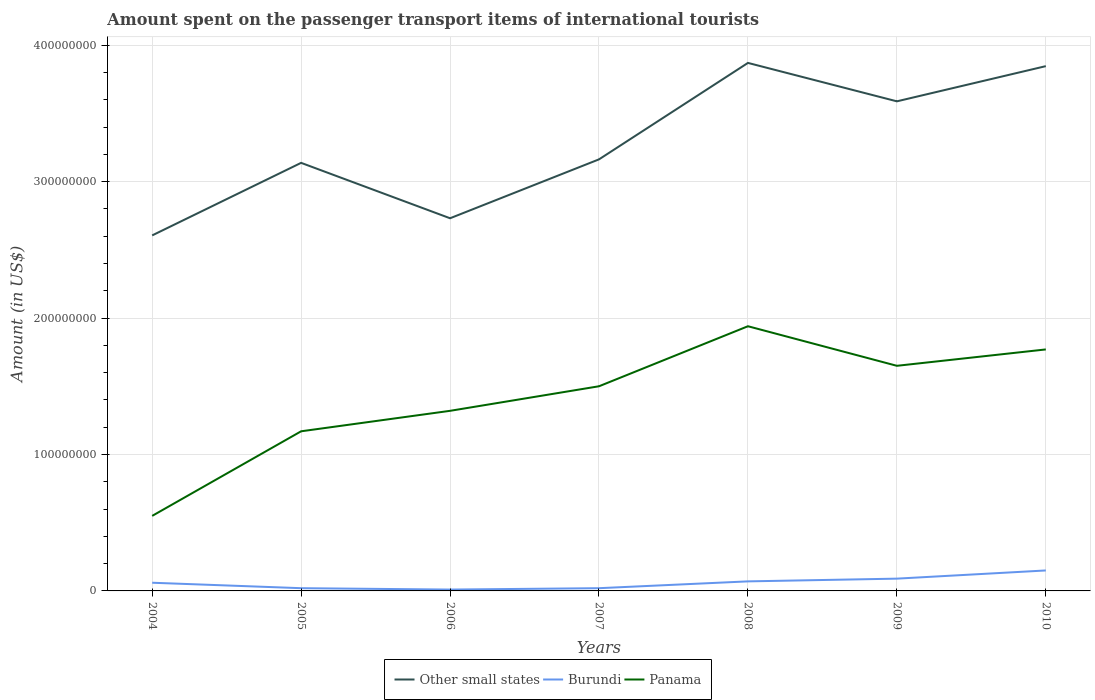How many different coloured lines are there?
Make the answer very short. 3. Is the number of lines equal to the number of legend labels?
Provide a short and direct response. Yes. What is the total amount spent on the passenger transport items of international tourists in Other small states in the graph?
Offer a terse response. -1.26e+08. What is the difference between the highest and the second highest amount spent on the passenger transport items of international tourists in Panama?
Offer a very short reply. 1.39e+08. Is the amount spent on the passenger transport items of international tourists in Burundi strictly greater than the amount spent on the passenger transport items of international tourists in Panama over the years?
Your answer should be very brief. Yes. How many lines are there?
Offer a very short reply. 3. How many years are there in the graph?
Offer a terse response. 7. What is the difference between two consecutive major ticks on the Y-axis?
Your answer should be very brief. 1.00e+08. Are the values on the major ticks of Y-axis written in scientific E-notation?
Give a very brief answer. No. Does the graph contain any zero values?
Make the answer very short. No. Where does the legend appear in the graph?
Give a very brief answer. Bottom center. How many legend labels are there?
Offer a terse response. 3. What is the title of the graph?
Offer a very short reply. Amount spent on the passenger transport items of international tourists. What is the label or title of the X-axis?
Make the answer very short. Years. What is the Amount (in US$) of Other small states in 2004?
Your answer should be very brief. 2.61e+08. What is the Amount (in US$) in Panama in 2004?
Make the answer very short. 5.50e+07. What is the Amount (in US$) in Other small states in 2005?
Provide a succinct answer. 3.14e+08. What is the Amount (in US$) of Panama in 2005?
Keep it short and to the point. 1.17e+08. What is the Amount (in US$) of Other small states in 2006?
Provide a succinct answer. 2.73e+08. What is the Amount (in US$) of Panama in 2006?
Your answer should be very brief. 1.32e+08. What is the Amount (in US$) of Other small states in 2007?
Keep it short and to the point. 3.16e+08. What is the Amount (in US$) in Panama in 2007?
Offer a terse response. 1.50e+08. What is the Amount (in US$) of Other small states in 2008?
Keep it short and to the point. 3.87e+08. What is the Amount (in US$) in Panama in 2008?
Ensure brevity in your answer.  1.94e+08. What is the Amount (in US$) of Other small states in 2009?
Make the answer very short. 3.59e+08. What is the Amount (in US$) of Burundi in 2009?
Your answer should be very brief. 9.00e+06. What is the Amount (in US$) of Panama in 2009?
Keep it short and to the point. 1.65e+08. What is the Amount (in US$) of Other small states in 2010?
Give a very brief answer. 3.85e+08. What is the Amount (in US$) in Burundi in 2010?
Provide a succinct answer. 1.50e+07. What is the Amount (in US$) of Panama in 2010?
Provide a short and direct response. 1.77e+08. Across all years, what is the maximum Amount (in US$) in Other small states?
Your answer should be compact. 3.87e+08. Across all years, what is the maximum Amount (in US$) in Burundi?
Your response must be concise. 1.50e+07. Across all years, what is the maximum Amount (in US$) of Panama?
Keep it short and to the point. 1.94e+08. Across all years, what is the minimum Amount (in US$) in Other small states?
Provide a succinct answer. 2.61e+08. Across all years, what is the minimum Amount (in US$) in Burundi?
Keep it short and to the point. 1.00e+06. Across all years, what is the minimum Amount (in US$) of Panama?
Your answer should be very brief. 5.50e+07. What is the total Amount (in US$) in Other small states in the graph?
Make the answer very short. 2.29e+09. What is the total Amount (in US$) in Burundi in the graph?
Make the answer very short. 4.20e+07. What is the total Amount (in US$) of Panama in the graph?
Your answer should be very brief. 9.90e+08. What is the difference between the Amount (in US$) in Other small states in 2004 and that in 2005?
Offer a very short reply. -5.32e+07. What is the difference between the Amount (in US$) in Burundi in 2004 and that in 2005?
Keep it short and to the point. 4.00e+06. What is the difference between the Amount (in US$) of Panama in 2004 and that in 2005?
Your response must be concise. -6.20e+07. What is the difference between the Amount (in US$) of Other small states in 2004 and that in 2006?
Your response must be concise. -1.26e+07. What is the difference between the Amount (in US$) in Panama in 2004 and that in 2006?
Ensure brevity in your answer.  -7.70e+07. What is the difference between the Amount (in US$) of Other small states in 2004 and that in 2007?
Your response must be concise. -5.57e+07. What is the difference between the Amount (in US$) of Panama in 2004 and that in 2007?
Your answer should be compact. -9.50e+07. What is the difference between the Amount (in US$) in Other small states in 2004 and that in 2008?
Your answer should be very brief. -1.26e+08. What is the difference between the Amount (in US$) in Panama in 2004 and that in 2008?
Offer a terse response. -1.39e+08. What is the difference between the Amount (in US$) of Other small states in 2004 and that in 2009?
Give a very brief answer. -9.83e+07. What is the difference between the Amount (in US$) in Burundi in 2004 and that in 2009?
Ensure brevity in your answer.  -3.00e+06. What is the difference between the Amount (in US$) of Panama in 2004 and that in 2009?
Provide a succinct answer. -1.10e+08. What is the difference between the Amount (in US$) of Other small states in 2004 and that in 2010?
Your answer should be compact. -1.24e+08. What is the difference between the Amount (in US$) of Burundi in 2004 and that in 2010?
Provide a succinct answer. -9.00e+06. What is the difference between the Amount (in US$) in Panama in 2004 and that in 2010?
Make the answer very short. -1.22e+08. What is the difference between the Amount (in US$) of Other small states in 2005 and that in 2006?
Ensure brevity in your answer.  4.06e+07. What is the difference between the Amount (in US$) of Panama in 2005 and that in 2006?
Keep it short and to the point. -1.50e+07. What is the difference between the Amount (in US$) of Other small states in 2005 and that in 2007?
Ensure brevity in your answer.  -2.56e+06. What is the difference between the Amount (in US$) of Panama in 2005 and that in 2007?
Provide a succinct answer. -3.30e+07. What is the difference between the Amount (in US$) in Other small states in 2005 and that in 2008?
Your response must be concise. -7.33e+07. What is the difference between the Amount (in US$) in Burundi in 2005 and that in 2008?
Give a very brief answer. -5.00e+06. What is the difference between the Amount (in US$) of Panama in 2005 and that in 2008?
Provide a succinct answer. -7.70e+07. What is the difference between the Amount (in US$) of Other small states in 2005 and that in 2009?
Keep it short and to the point. -4.51e+07. What is the difference between the Amount (in US$) in Burundi in 2005 and that in 2009?
Provide a short and direct response. -7.00e+06. What is the difference between the Amount (in US$) in Panama in 2005 and that in 2009?
Provide a short and direct response. -4.80e+07. What is the difference between the Amount (in US$) of Other small states in 2005 and that in 2010?
Provide a succinct answer. -7.09e+07. What is the difference between the Amount (in US$) of Burundi in 2005 and that in 2010?
Ensure brevity in your answer.  -1.30e+07. What is the difference between the Amount (in US$) in Panama in 2005 and that in 2010?
Your answer should be compact. -6.00e+07. What is the difference between the Amount (in US$) in Other small states in 2006 and that in 2007?
Ensure brevity in your answer.  -4.32e+07. What is the difference between the Amount (in US$) in Panama in 2006 and that in 2007?
Ensure brevity in your answer.  -1.80e+07. What is the difference between the Amount (in US$) in Other small states in 2006 and that in 2008?
Offer a very short reply. -1.14e+08. What is the difference between the Amount (in US$) in Burundi in 2006 and that in 2008?
Give a very brief answer. -6.00e+06. What is the difference between the Amount (in US$) of Panama in 2006 and that in 2008?
Give a very brief answer. -6.20e+07. What is the difference between the Amount (in US$) in Other small states in 2006 and that in 2009?
Provide a succinct answer. -8.57e+07. What is the difference between the Amount (in US$) of Burundi in 2006 and that in 2009?
Give a very brief answer. -8.00e+06. What is the difference between the Amount (in US$) in Panama in 2006 and that in 2009?
Provide a short and direct response. -3.30e+07. What is the difference between the Amount (in US$) in Other small states in 2006 and that in 2010?
Make the answer very short. -1.11e+08. What is the difference between the Amount (in US$) in Burundi in 2006 and that in 2010?
Keep it short and to the point. -1.40e+07. What is the difference between the Amount (in US$) in Panama in 2006 and that in 2010?
Your response must be concise. -4.50e+07. What is the difference between the Amount (in US$) of Other small states in 2007 and that in 2008?
Your response must be concise. -7.07e+07. What is the difference between the Amount (in US$) in Burundi in 2007 and that in 2008?
Ensure brevity in your answer.  -5.00e+06. What is the difference between the Amount (in US$) in Panama in 2007 and that in 2008?
Give a very brief answer. -4.40e+07. What is the difference between the Amount (in US$) of Other small states in 2007 and that in 2009?
Your answer should be very brief. -4.25e+07. What is the difference between the Amount (in US$) in Burundi in 2007 and that in 2009?
Your answer should be compact. -7.00e+06. What is the difference between the Amount (in US$) in Panama in 2007 and that in 2009?
Offer a very short reply. -1.50e+07. What is the difference between the Amount (in US$) of Other small states in 2007 and that in 2010?
Provide a succinct answer. -6.83e+07. What is the difference between the Amount (in US$) of Burundi in 2007 and that in 2010?
Offer a very short reply. -1.30e+07. What is the difference between the Amount (in US$) in Panama in 2007 and that in 2010?
Offer a very short reply. -2.70e+07. What is the difference between the Amount (in US$) in Other small states in 2008 and that in 2009?
Offer a terse response. 2.82e+07. What is the difference between the Amount (in US$) in Panama in 2008 and that in 2009?
Offer a terse response. 2.90e+07. What is the difference between the Amount (in US$) of Other small states in 2008 and that in 2010?
Provide a short and direct response. 2.37e+06. What is the difference between the Amount (in US$) in Burundi in 2008 and that in 2010?
Offer a terse response. -8.00e+06. What is the difference between the Amount (in US$) of Panama in 2008 and that in 2010?
Ensure brevity in your answer.  1.70e+07. What is the difference between the Amount (in US$) in Other small states in 2009 and that in 2010?
Your answer should be very brief. -2.58e+07. What is the difference between the Amount (in US$) of Burundi in 2009 and that in 2010?
Offer a very short reply. -6.00e+06. What is the difference between the Amount (in US$) of Panama in 2009 and that in 2010?
Offer a terse response. -1.20e+07. What is the difference between the Amount (in US$) in Other small states in 2004 and the Amount (in US$) in Burundi in 2005?
Your answer should be compact. 2.59e+08. What is the difference between the Amount (in US$) of Other small states in 2004 and the Amount (in US$) of Panama in 2005?
Keep it short and to the point. 1.44e+08. What is the difference between the Amount (in US$) in Burundi in 2004 and the Amount (in US$) in Panama in 2005?
Your answer should be very brief. -1.11e+08. What is the difference between the Amount (in US$) in Other small states in 2004 and the Amount (in US$) in Burundi in 2006?
Your answer should be compact. 2.60e+08. What is the difference between the Amount (in US$) of Other small states in 2004 and the Amount (in US$) of Panama in 2006?
Your response must be concise. 1.29e+08. What is the difference between the Amount (in US$) of Burundi in 2004 and the Amount (in US$) of Panama in 2006?
Your answer should be very brief. -1.26e+08. What is the difference between the Amount (in US$) in Other small states in 2004 and the Amount (in US$) in Burundi in 2007?
Your answer should be very brief. 2.59e+08. What is the difference between the Amount (in US$) of Other small states in 2004 and the Amount (in US$) of Panama in 2007?
Keep it short and to the point. 1.11e+08. What is the difference between the Amount (in US$) in Burundi in 2004 and the Amount (in US$) in Panama in 2007?
Offer a very short reply. -1.44e+08. What is the difference between the Amount (in US$) of Other small states in 2004 and the Amount (in US$) of Burundi in 2008?
Your response must be concise. 2.54e+08. What is the difference between the Amount (in US$) of Other small states in 2004 and the Amount (in US$) of Panama in 2008?
Ensure brevity in your answer.  6.66e+07. What is the difference between the Amount (in US$) in Burundi in 2004 and the Amount (in US$) in Panama in 2008?
Give a very brief answer. -1.88e+08. What is the difference between the Amount (in US$) of Other small states in 2004 and the Amount (in US$) of Burundi in 2009?
Keep it short and to the point. 2.52e+08. What is the difference between the Amount (in US$) in Other small states in 2004 and the Amount (in US$) in Panama in 2009?
Offer a terse response. 9.56e+07. What is the difference between the Amount (in US$) in Burundi in 2004 and the Amount (in US$) in Panama in 2009?
Give a very brief answer. -1.59e+08. What is the difference between the Amount (in US$) in Other small states in 2004 and the Amount (in US$) in Burundi in 2010?
Provide a succinct answer. 2.46e+08. What is the difference between the Amount (in US$) in Other small states in 2004 and the Amount (in US$) in Panama in 2010?
Your answer should be compact. 8.36e+07. What is the difference between the Amount (in US$) of Burundi in 2004 and the Amount (in US$) of Panama in 2010?
Make the answer very short. -1.71e+08. What is the difference between the Amount (in US$) of Other small states in 2005 and the Amount (in US$) of Burundi in 2006?
Make the answer very short. 3.13e+08. What is the difference between the Amount (in US$) of Other small states in 2005 and the Amount (in US$) of Panama in 2006?
Ensure brevity in your answer.  1.82e+08. What is the difference between the Amount (in US$) in Burundi in 2005 and the Amount (in US$) in Panama in 2006?
Offer a very short reply. -1.30e+08. What is the difference between the Amount (in US$) of Other small states in 2005 and the Amount (in US$) of Burundi in 2007?
Provide a succinct answer. 3.12e+08. What is the difference between the Amount (in US$) of Other small states in 2005 and the Amount (in US$) of Panama in 2007?
Ensure brevity in your answer.  1.64e+08. What is the difference between the Amount (in US$) in Burundi in 2005 and the Amount (in US$) in Panama in 2007?
Your answer should be compact. -1.48e+08. What is the difference between the Amount (in US$) in Other small states in 2005 and the Amount (in US$) in Burundi in 2008?
Provide a succinct answer. 3.07e+08. What is the difference between the Amount (in US$) in Other small states in 2005 and the Amount (in US$) in Panama in 2008?
Give a very brief answer. 1.20e+08. What is the difference between the Amount (in US$) of Burundi in 2005 and the Amount (in US$) of Panama in 2008?
Offer a very short reply. -1.92e+08. What is the difference between the Amount (in US$) of Other small states in 2005 and the Amount (in US$) of Burundi in 2009?
Provide a succinct answer. 3.05e+08. What is the difference between the Amount (in US$) of Other small states in 2005 and the Amount (in US$) of Panama in 2009?
Your answer should be very brief. 1.49e+08. What is the difference between the Amount (in US$) of Burundi in 2005 and the Amount (in US$) of Panama in 2009?
Offer a terse response. -1.63e+08. What is the difference between the Amount (in US$) in Other small states in 2005 and the Amount (in US$) in Burundi in 2010?
Keep it short and to the point. 2.99e+08. What is the difference between the Amount (in US$) of Other small states in 2005 and the Amount (in US$) of Panama in 2010?
Keep it short and to the point. 1.37e+08. What is the difference between the Amount (in US$) in Burundi in 2005 and the Amount (in US$) in Panama in 2010?
Make the answer very short. -1.75e+08. What is the difference between the Amount (in US$) in Other small states in 2006 and the Amount (in US$) in Burundi in 2007?
Keep it short and to the point. 2.71e+08. What is the difference between the Amount (in US$) in Other small states in 2006 and the Amount (in US$) in Panama in 2007?
Offer a terse response. 1.23e+08. What is the difference between the Amount (in US$) in Burundi in 2006 and the Amount (in US$) in Panama in 2007?
Keep it short and to the point. -1.49e+08. What is the difference between the Amount (in US$) in Other small states in 2006 and the Amount (in US$) in Burundi in 2008?
Your response must be concise. 2.66e+08. What is the difference between the Amount (in US$) of Other small states in 2006 and the Amount (in US$) of Panama in 2008?
Your response must be concise. 7.91e+07. What is the difference between the Amount (in US$) of Burundi in 2006 and the Amount (in US$) of Panama in 2008?
Keep it short and to the point. -1.93e+08. What is the difference between the Amount (in US$) in Other small states in 2006 and the Amount (in US$) in Burundi in 2009?
Make the answer very short. 2.64e+08. What is the difference between the Amount (in US$) in Other small states in 2006 and the Amount (in US$) in Panama in 2009?
Make the answer very short. 1.08e+08. What is the difference between the Amount (in US$) of Burundi in 2006 and the Amount (in US$) of Panama in 2009?
Make the answer very short. -1.64e+08. What is the difference between the Amount (in US$) of Other small states in 2006 and the Amount (in US$) of Burundi in 2010?
Your answer should be very brief. 2.58e+08. What is the difference between the Amount (in US$) in Other small states in 2006 and the Amount (in US$) in Panama in 2010?
Your answer should be very brief. 9.61e+07. What is the difference between the Amount (in US$) of Burundi in 2006 and the Amount (in US$) of Panama in 2010?
Give a very brief answer. -1.76e+08. What is the difference between the Amount (in US$) of Other small states in 2007 and the Amount (in US$) of Burundi in 2008?
Provide a short and direct response. 3.09e+08. What is the difference between the Amount (in US$) of Other small states in 2007 and the Amount (in US$) of Panama in 2008?
Your answer should be compact. 1.22e+08. What is the difference between the Amount (in US$) in Burundi in 2007 and the Amount (in US$) in Panama in 2008?
Make the answer very short. -1.92e+08. What is the difference between the Amount (in US$) in Other small states in 2007 and the Amount (in US$) in Burundi in 2009?
Offer a very short reply. 3.07e+08. What is the difference between the Amount (in US$) of Other small states in 2007 and the Amount (in US$) of Panama in 2009?
Your response must be concise. 1.51e+08. What is the difference between the Amount (in US$) of Burundi in 2007 and the Amount (in US$) of Panama in 2009?
Your response must be concise. -1.63e+08. What is the difference between the Amount (in US$) of Other small states in 2007 and the Amount (in US$) of Burundi in 2010?
Offer a very short reply. 3.01e+08. What is the difference between the Amount (in US$) in Other small states in 2007 and the Amount (in US$) in Panama in 2010?
Your answer should be very brief. 1.39e+08. What is the difference between the Amount (in US$) in Burundi in 2007 and the Amount (in US$) in Panama in 2010?
Provide a succinct answer. -1.75e+08. What is the difference between the Amount (in US$) in Other small states in 2008 and the Amount (in US$) in Burundi in 2009?
Give a very brief answer. 3.78e+08. What is the difference between the Amount (in US$) of Other small states in 2008 and the Amount (in US$) of Panama in 2009?
Keep it short and to the point. 2.22e+08. What is the difference between the Amount (in US$) of Burundi in 2008 and the Amount (in US$) of Panama in 2009?
Give a very brief answer. -1.58e+08. What is the difference between the Amount (in US$) of Other small states in 2008 and the Amount (in US$) of Burundi in 2010?
Provide a short and direct response. 3.72e+08. What is the difference between the Amount (in US$) of Other small states in 2008 and the Amount (in US$) of Panama in 2010?
Your answer should be compact. 2.10e+08. What is the difference between the Amount (in US$) in Burundi in 2008 and the Amount (in US$) in Panama in 2010?
Your answer should be very brief. -1.70e+08. What is the difference between the Amount (in US$) in Other small states in 2009 and the Amount (in US$) in Burundi in 2010?
Your response must be concise. 3.44e+08. What is the difference between the Amount (in US$) of Other small states in 2009 and the Amount (in US$) of Panama in 2010?
Provide a short and direct response. 1.82e+08. What is the difference between the Amount (in US$) of Burundi in 2009 and the Amount (in US$) of Panama in 2010?
Give a very brief answer. -1.68e+08. What is the average Amount (in US$) in Other small states per year?
Offer a terse response. 3.28e+08. What is the average Amount (in US$) of Burundi per year?
Give a very brief answer. 6.00e+06. What is the average Amount (in US$) of Panama per year?
Your answer should be compact. 1.41e+08. In the year 2004, what is the difference between the Amount (in US$) of Other small states and Amount (in US$) of Burundi?
Your answer should be very brief. 2.55e+08. In the year 2004, what is the difference between the Amount (in US$) of Other small states and Amount (in US$) of Panama?
Ensure brevity in your answer.  2.06e+08. In the year 2004, what is the difference between the Amount (in US$) of Burundi and Amount (in US$) of Panama?
Your answer should be very brief. -4.90e+07. In the year 2005, what is the difference between the Amount (in US$) of Other small states and Amount (in US$) of Burundi?
Give a very brief answer. 3.12e+08. In the year 2005, what is the difference between the Amount (in US$) of Other small states and Amount (in US$) of Panama?
Ensure brevity in your answer.  1.97e+08. In the year 2005, what is the difference between the Amount (in US$) of Burundi and Amount (in US$) of Panama?
Provide a short and direct response. -1.15e+08. In the year 2006, what is the difference between the Amount (in US$) of Other small states and Amount (in US$) of Burundi?
Provide a short and direct response. 2.72e+08. In the year 2006, what is the difference between the Amount (in US$) of Other small states and Amount (in US$) of Panama?
Your answer should be very brief. 1.41e+08. In the year 2006, what is the difference between the Amount (in US$) of Burundi and Amount (in US$) of Panama?
Your answer should be very brief. -1.31e+08. In the year 2007, what is the difference between the Amount (in US$) in Other small states and Amount (in US$) in Burundi?
Give a very brief answer. 3.14e+08. In the year 2007, what is the difference between the Amount (in US$) in Other small states and Amount (in US$) in Panama?
Your answer should be very brief. 1.66e+08. In the year 2007, what is the difference between the Amount (in US$) of Burundi and Amount (in US$) of Panama?
Your response must be concise. -1.48e+08. In the year 2008, what is the difference between the Amount (in US$) in Other small states and Amount (in US$) in Burundi?
Your answer should be compact. 3.80e+08. In the year 2008, what is the difference between the Amount (in US$) of Other small states and Amount (in US$) of Panama?
Your answer should be very brief. 1.93e+08. In the year 2008, what is the difference between the Amount (in US$) of Burundi and Amount (in US$) of Panama?
Keep it short and to the point. -1.87e+08. In the year 2009, what is the difference between the Amount (in US$) in Other small states and Amount (in US$) in Burundi?
Offer a very short reply. 3.50e+08. In the year 2009, what is the difference between the Amount (in US$) of Other small states and Amount (in US$) of Panama?
Offer a very short reply. 1.94e+08. In the year 2009, what is the difference between the Amount (in US$) of Burundi and Amount (in US$) of Panama?
Provide a succinct answer. -1.56e+08. In the year 2010, what is the difference between the Amount (in US$) in Other small states and Amount (in US$) in Burundi?
Keep it short and to the point. 3.70e+08. In the year 2010, what is the difference between the Amount (in US$) of Other small states and Amount (in US$) of Panama?
Your answer should be very brief. 2.08e+08. In the year 2010, what is the difference between the Amount (in US$) of Burundi and Amount (in US$) of Panama?
Your answer should be very brief. -1.62e+08. What is the ratio of the Amount (in US$) in Other small states in 2004 to that in 2005?
Your response must be concise. 0.83. What is the ratio of the Amount (in US$) of Panama in 2004 to that in 2005?
Your answer should be very brief. 0.47. What is the ratio of the Amount (in US$) in Other small states in 2004 to that in 2006?
Make the answer very short. 0.95. What is the ratio of the Amount (in US$) in Burundi in 2004 to that in 2006?
Your answer should be very brief. 6. What is the ratio of the Amount (in US$) in Panama in 2004 to that in 2006?
Ensure brevity in your answer.  0.42. What is the ratio of the Amount (in US$) of Other small states in 2004 to that in 2007?
Ensure brevity in your answer.  0.82. What is the ratio of the Amount (in US$) in Burundi in 2004 to that in 2007?
Your answer should be very brief. 3. What is the ratio of the Amount (in US$) of Panama in 2004 to that in 2007?
Provide a succinct answer. 0.37. What is the ratio of the Amount (in US$) of Other small states in 2004 to that in 2008?
Give a very brief answer. 0.67. What is the ratio of the Amount (in US$) in Burundi in 2004 to that in 2008?
Keep it short and to the point. 0.86. What is the ratio of the Amount (in US$) of Panama in 2004 to that in 2008?
Your answer should be compact. 0.28. What is the ratio of the Amount (in US$) in Other small states in 2004 to that in 2009?
Make the answer very short. 0.73. What is the ratio of the Amount (in US$) of Burundi in 2004 to that in 2009?
Provide a short and direct response. 0.67. What is the ratio of the Amount (in US$) of Other small states in 2004 to that in 2010?
Your answer should be compact. 0.68. What is the ratio of the Amount (in US$) of Burundi in 2004 to that in 2010?
Your answer should be compact. 0.4. What is the ratio of the Amount (in US$) of Panama in 2004 to that in 2010?
Offer a terse response. 0.31. What is the ratio of the Amount (in US$) of Other small states in 2005 to that in 2006?
Make the answer very short. 1.15. What is the ratio of the Amount (in US$) of Burundi in 2005 to that in 2006?
Give a very brief answer. 2. What is the ratio of the Amount (in US$) of Panama in 2005 to that in 2006?
Provide a succinct answer. 0.89. What is the ratio of the Amount (in US$) in Other small states in 2005 to that in 2007?
Ensure brevity in your answer.  0.99. What is the ratio of the Amount (in US$) of Panama in 2005 to that in 2007?
Ensure brevity in your answer.  0.78. What is the ratio of the Amount (in US$) in Other small states in 2005 to that in 2008?
Offer a terse response. 0.81. What is the ratio of the Amount (in US$) of Burundi in 2005 to that in 2008?
Make the answer very short. 0.29. What is the ratio of the Amount (in US$) in Panama in 2005 to that in 2008?
Ensure brevity in your answer.  0.6. What is the ratio of the Amount (in US$) of Other small states in 2005 to that in 2009?
Provide a succinct answer. 0.87. What is the ratio of the Amount (in US$) of Burundi in 2005 to that in 2009?
Your response must be concise. 0.22. What is the ratio of the Amount (in US$) of Panama in 2005 to that in 2009?
Give a very brief answer. 0.71. What is the ratio of the Amount (in US$) of Other small states in 2005 to that in 2010?
Keep it short and to the point. 0.82. What is the ratio of the Amount (in US$) of Burundi in 2005 to that in 2010?
Offer a terse response. 0.13. What is the ratio of the Amount (in US$) in Panama in 2005 to that in 2010?
Provide a short and direct response. 0.66. What is the ratio of the Amount (in US$) of Other small states in 2006 to that in 2007?
Provide a short and direct response. 0.86. What is the ratio of the Amount (in US$) in Panama in 2006 to that in 2007?
Your response must be concise. 0.88. What is the ratio of the Amount (in US$) in Other small states in 2006 to that in 2008?
Keep it short and to the point. 0.71. What is the ratio of the Amount (in US$) of Burundi in 2006 to that in 2008?
Ensure brevity in your answer.  0.14. What is the ratio of the Amount (in US$) of Panama in 2006 to that in 2008?
Your answer should be compact. 0.68. What is the ratio of the Amount (in US$) in Other small states in 2006 to that in 2009?
Keep it short and to the point. 0.76. What is the ratio of the Amount (in US$) in Panama in 2006 to that in 2009?
Your answer should be very brief. 0.8. What is the ratio of the Amount (in US$) in Other small states in 2006 to that in 2010?
Provide a succinct answer. 0.71. What is the ratio of the Amount (in US$) in Burundi in 2006 to that in 2010?
Your answer should be compact. 0.07. What is the ratio of the Amount (in US$) in Panama in 2006 to that in 2010?
Give a very brief answer. 0.75. What is the ratio of the Amount (in US$) of Other small states in 2007 to that in 2008?
Your answer should be compact. 0.82. What is the ratio of the Amount (in US$) in Burundi in 2007 to that in 2008?
Offer a very short reply. 0.29. What is the ratio of the Amount (in US$) of Panama in 2007 to that in 2008?
Provide a short and direct response. 0.77. What is the ratio of the Amount (in US$) in Other small states in 2007 to that in 2009?
Your answer should be very brief. 0.88. What is the ratio of the Amount (in US$) of Burundi in 2007 to that in 2009?
Offer a terse response. 0.22. What is the ratio of the Amount (in US$) in Other small states in 2007 to that in 2010?
Ensure brevity in your answer.  0.82. What is the ratio of the Amount (in US$) in Burundi in 2007 to that in 2010?
Provide a succinct answer. 0.13. What is the ratio of the Amount (in US$) of Panama in 2007 to that in 2010?
Keep it short and to the point. 0.85. What is the ratio of the Amount (in US$) in Other small states in 2008 to that in 2009?
Ensure brevity in your answer.  1.08. What is the ratio of the Amount (in US$) of Burundi in 2008 to that in 2009?
Provide a short and direct response. 0.78. What is the ratio of the Amount (in US$) in Panama in 2008 to that in 2009?
Provide a short and direct response. 1.18. What is the ratio of the Amount (in US$) of Other small states in 2008 to that in 2010?
Ensure brevity in your answer.  1.01. What is the ratio of the Amount (in US$) of Burundi in 2008 to that in 2010?
Your answer should be compact. 0.47. What is the ratio of the Amount (in US$) in Panama in 2008 to that in 2010?
Provide a short and direct response. 1.1. What is the ratio of the Amount (in US$) in Other small states in 2009 to that in 2010?
Offer a terse response. 0.93. What is the ratio of the Amount (in US$) of Panama in 2009 to that in 2010?
Your answer should be very brief. 0.93. What is the difference between the highest and the second highest Amount (in US$) in Other small states?
Offer a very short reply. 2.37e+06. What is the difference between the highest and the second highest Amount (in US$) in Burundi?
Offer a very short reply. 6.00e+06. What is the difference between the highest and the second highest Amount (in US$) in Panama?
Your answer should be compact. 1.70e+07. What is the difference between the highest and the lowest Amount (in US$) in Other small states?
Keep it short and to the point. 1.26e+08. What is the difference between the highest and the lowest Amount (in US$) of Burundi?
Your response must be concise. 1.40e+07. What is the difference between the highest and the lowest Amount (in US$) in Panama?
Your answer should be compact. 1.39e+08. 